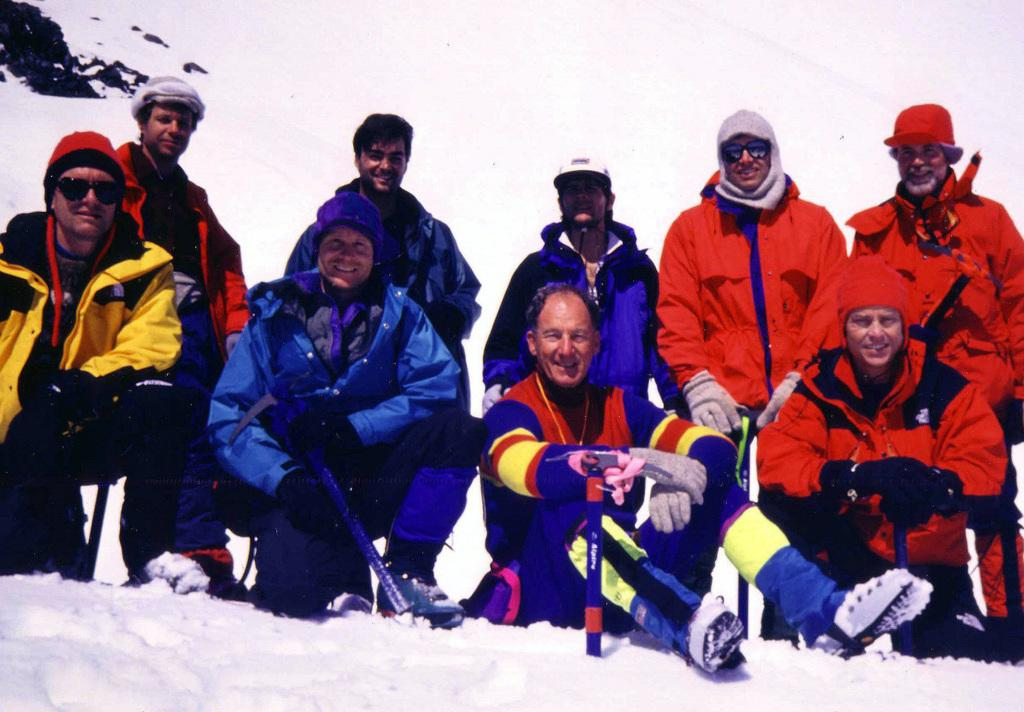How many people are in the image? There is a group of people in the image, but the exact number is not specified. What is the setting of the image? The people are on the snow. What instrument is the person A attempting to play in the image? There is no instrument present in the image, and no person is attempting to play anything. 